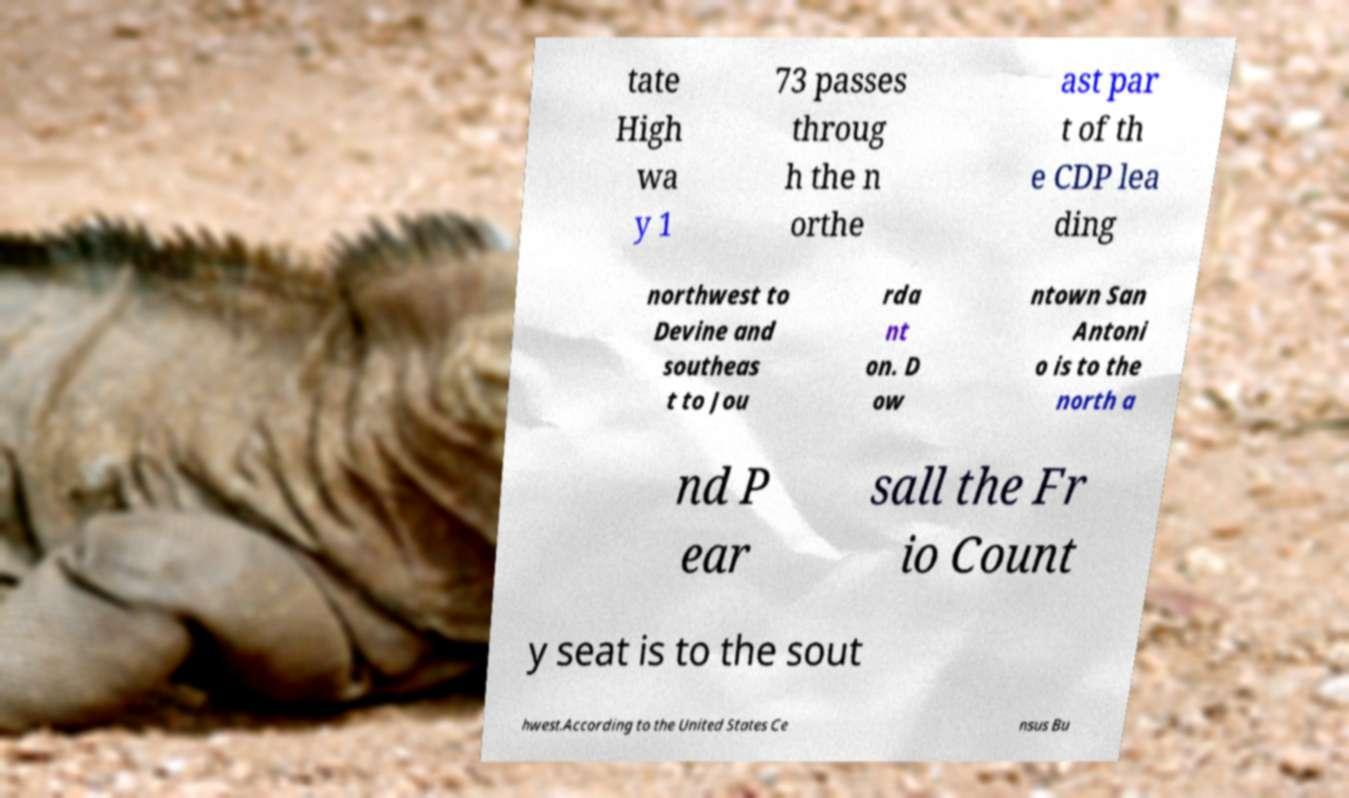For documentation purposes, I need the text within this image transcribed. Could you provide that? tate High wa y 1 73 passes throug h the n orthe ast par t of th e CDP lea ding northwest to Devine and southeas t to Jou rda nt on. D ow ntown San Antoni o is to the north a nd P ear sall the Fr io Count y seat is to the sout hwest.According to the United States Ce nsus Bu 